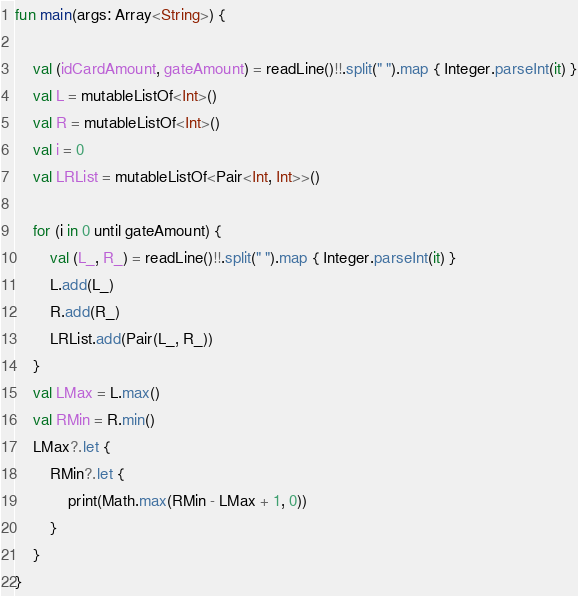Convert code to text. <code><loc_0><loc_0><loc_500><loc_500><_Kotlin_>fun main(args: Array<String>) {

    val (idCardAmount, gateAmount) = readLine()!!.split(" ").map { Integer.parseInt(it) }
    val L = mutableListOf<Int>()
    val R = mutableListOf<Int>()
    val i = 0
    val LRList = mutableListOf<Pair<Int, Int>>()

    for (i in 0 until gateAmount) {
        val (L_, R_) = readLine()!!.split(" ").map { Integer.parseInt(it) }
        L.add(L_)
        R.add(R_)
        LRList.add(Pair(L_, R_))
    }
    val LMax = L.max()
    val RMin = R.min()
    LMax?.let {
        RMin?.let {
            print(Math.max(RMin - LMax + 1, 0))
        }
    }
}</code> 